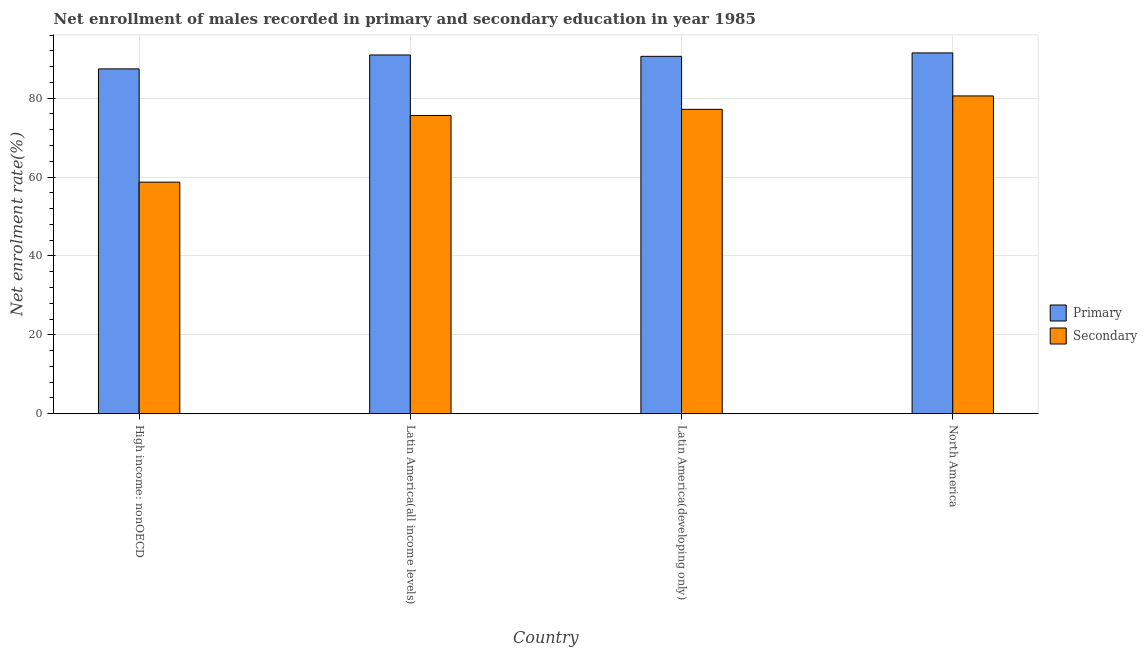Are the number of bars per tick equal to the number of legend labels?
Your response must be concise. Yes. How many bars are there on the 4th tick from the right?
Provide a succinct answer. 2. What is the enrollment rate in secondary education in North America?
Offer a terse response. 80.57. Across all countries, what is the maximum enrollment rate in primary education?
Ensure brevity in your answer.  91.47. Across all countries, what is the minimum enrollment rate in secondary education?
Your answer should be compact. 58.71. In which country was the enrollment rate in primary education maximum?
Ensure brevity in your answer.  North America. In which country was the enrollment rate in primary education minimum?
Provide a succinct answer. High income: nonOECD. What is the total enrollment rate in secondary education in the graph?
Give a very brief answer. 292.08. What is the difference between the enrollment rate in secondary education in High income: nonOECD and that in Latin America(all income levels)?
Keep it short and to the point. -16.91. What is the difference between the enrollment rate in primary education in High income: nonOECD and the enrollment rate in secondary education in North America?
Your response must be concise. 6.85. What is the average enrollment rate in primary education per country?
Ensure brevity in your answer.  90.11. What is the difference between the enrollment rate in secondary education and enrollment rate in primary education in High income: nonOECD?
Your answer should be compact. -28.71. In how many countries, is the enrollment rate in primary education greater than 44 %?
Give a very brief answer. 4. What is the ratio of the enrollment rate in secondary education in High income: nonOECD to that in North America?
Provide a succinct answer. 0.73. Is the enrollment rate in secondary education in High income: nonOECD less than that in Latin America(all income levels)?
Your response must be concise. Yes. Is the difference between the enrollment rate in primary education in High income: nonOECD and Latin America(all income levels) greater than the difference between the enrollment rate in secondary education in High income: nonOECD and Latin America(all income levels)?
Your answer should be very brief. Yes. What is the difference between the highest and the second highest enrollment rate in secondary education?
Make the answer very short. 3.4. What is the difference between the highest and the lowest enrollment rate in secondary education?
Offer a very short reply. 21.86. Is the sum of the enrollment rate in secondary education in Latin America(developing only) and North America greater than the maximum enrollment rate in primary education across all countries?
Keep it short and to the point. Yes. What does the 2nd bar from the left in Latin America(developing only) represents?
Your answer should be very brief. Secondary. What does the 2nd bar from the right in High income: nonOECD represents?
Give a very brief answer. Primary. Are all the bars in the graph horizontal?
Provide a succinct answer. No. How many countries are there in the graph?
Your answer should be very brief. 4. What is the difference between two consecutive major ticks on the Y-axis?
Provide a succinct answer. 20. Does the graph contain any zero values?
Give a very brief answer. No. Where does the legend appear in the graph?
Make the answer very short. Center right. What is the title of the graph?
Your answer should be very brief. Net enrollment of males recorded in primary and secondary education in year 1985. Does "Forest" appear as one of the legend labels in the graph?
Offer a terse response. No. What is the label or title of the X-axis?
Your answer should be compact. Country. What is the label or title of the Y-axis?
Your answer should be very brief. Net enrolment rate(%). What is the Net enrolment rate(%) in Primary in High income: nonOECD?
Offer a very short reply. 87.42. What is the Net enrolment rate(%) in Secondary in High income: nonOECD?
Your response must be concise. 58.71. What is the Net enrolment rate(%) of Primary in Latin America(all income levels)?
Your response must be concise. 90.95. What is the Net enrolment rate(%) in Secondary in Latin America(all income levels)?
Ensure brevity in your answer.  75.62. What is the Net enrolment rate(%) of Primary in Latin America(developing only)?
Ensure brevity in your answer.  90.61. What is the Net enrolment rate(%) in Secondary in Latin America(developing only)?
Your response must be concise. 77.17. What is the Net enrolment rate(%) of Primary in North America?
Offer a very short reply. 91.47. What is the Net enrolment rate(%) of Secondary in North America?
Your answer should be compact. 80.57. Across all countries, what is the maximum Net enrolment rate(%) of Primary?
Keep it short and to the point. 91.47. Across all countries, what is the maximum Net enrolment rate(%) in Secondary?
Offer a terse response. 80.57. Across all countries, what is the minimum Net enrolment rate(%) in Primary?
Your answer should be compact. 87.42. Across all countries, what is the minimum Net enrolment rate(%) in Secondary?
Your response must be concise. 58.71. What is the total Net enrolment rate(%) of Primary in the graph?
Offer a terse response. 360.46. What is the total Net enrolment rate(%) of Secondary in the graph?
Your response must be concise. 292.08. What is the difference between the Net enrolment rate(%) in Primary in High income: nonOECD and that in Latin America(all income levels)?
Make the answer very short. -3.53. What is the difference between the Net enrolment rate(%) of Secondary in High income: nonOECD and that in Latin America(all income levels)?
Give a very brief answer. -16.91. What is the difference between the Net enrolment rate(%) of Primary in High income: nonOECD and that in Latin America(developing only)?
Your response must be concise. -3.19. What is the difference between the Net enrolment rate(%) in Secondary in High income: nonOECD and that in Latin America(developing only)?
Ensure brevity in your answer.  -18.46. What is the difference between the Net enrolment rate(%) in Primary in High income: nonOECD and that in North America?
Make the answer very short. -4.05. What is the difference between the Net enrolment rate(%) of Secondary in High income: nonOECD and that in North America?
Offer a terse response. -21.86. What is the difference between the Net enrolment rate(%) in Primary in Latin America(all income levels) and that in Latin America(developing only)?
Make the answer very short. 0.34. What is the difference between the Net enrolment rate(%) of Secondary in Latin America(all income levels) and that in Latin America(developing only)?
Your answer should be compact. -1.55. What is the difference between the Net enrolment rate(%) of Primary in Latin America(all income levels) and that in North America?
Provide a short and direct response. -0.52. What is the difference between the Net enrolment rate(%) of Secondary in Latin America(all income levels) and that in North America?
Make the answer very short. -4.95. What is the difference between the Net enrolment rate(%) of Primary in Latin America(developing only) and that in North America?
Offer a terse response. -0.87. What is the difference between the Net enrolment rate(%) in Secondary in Latin America(developing only) and that in North America?
Your answer should be very brief. -3.4. What is the difference between the Net enrolment rate(%) in Primary in High income: nonOECD and the Net enrolment rate(%) in Secondary in Latin America(all income levels)?
Provide a succinct answer. 11.8. What is the difference between the Net enrolment rate(%) in Primary in High income: nonOECD and the Net enrolment rate(%) in Secondary in Latin America(developing only)?
Give a very brief answer. 10.25. What is the difference between the Net enrolment rate(%) in Primary in High income: nonOECD and the Net enrolment rate(%) in Secondary in North America?
Give a very brief answer. 6.85. What is the difference between the Net enrolment rate(%) of Primary in Latin America(all income levels) and the Net enrolment rate(%) of Secondary in Latin America(developing only)?
Give a very brief answer. 13.78. What is the difference between the Net enrolment rate(%) in Primary in Latin America(all income levels) and the Net enrolment rate(%) in Secondary in North America?
Your answer should be compact. 10.38. What is the difference between the Net enrolment rate(%) of Primary in Latin America(developing only) and the Net enrolment rate(%) of Secondary in North America?
Offer a terse response. 10.04. What is the average Net enrolment rate(%) of Primary per country?
Ensure brevity in your answer.  90.11. What is the average Net enrolment rate(%) in Secondary per country?
Keep it short and to the point. 73.02. What is the difference between the Net enrolment rate(%) of Primary and Net enrolment rate(%) of Secondary in High income: nonOECD?
Provide a succinct answer. 28.71. What is the difference between the Net enrolment rate(%) in Primary and Net enrolment rate(%) in Secondary in Latin America(all income levels)?
Offer a terse response. 15.33. What is the difference between the Net enrolment rate(%) in Primary and Net enrolment rate(%) in Secondary in Latin America(developing only)?
Ensure brevity in your answer.  13.44. What is the difference between the Net enrolment rate(%) in Primary and Net enrolment rate(%) in Secondary in North America?
Your answer should be very brief. 10.9. What is the ratio of the Net enrolment rate(%) in Primary in High income: nonOECD to that in Latin America(all income levels)?
Ensure brevity in your answer.  0.96. What is the ratio of the Net enrolment rate(%) of Secondary in High income: nonOECD to that in Latin America(all income levels)?
Give a very brief answer. 0.78. What is the ratio of the Net enrolment rate(%) in Primary in High income: nonOECD to that in Latin America(developing only)?
Give a very brief answer. 0.96. What is the ratio of the Net enrolment rate(%) of Secondary in High income: nonOECD to that in Latin America(developing only)?
Offer a terse response. 0.76. What is the ratio of the Net enrolment rate(%) of Primary in High income: nonOECD to that in North America?
Provide a succinct answer. 0.96. What is the ratio of the Net enrolment rate(%) in Secondary in High income: nonOECD to that in North America?
Give a very brief answer. 0.73. What is the ratio of the Net enrolment rate(%) in Secondary in Latin America(all income levels) to that in Latin America(developing only)?
Your answer should be compact. 0.98. What is the ratio of the Net enrolment rate(%) in Primary in Latin America(all income levels) to that in North America?
Provide a succinct answer. 0.99. What is the ratio of the Net enrolment rate(%) of Secondary in Latin America(all income levels) to that in North America?
Your answer should be compact. 0.94. What is the ratio of the Net enrolment rate(%) in Secondary in Latin America(developing only) to that in North America?
Provide a succinct answer. 0.96. What is the difference between the highest and the second highest Net enrolment rate(%) of Primary?
Provide a succinct answer. 0.52. What is the difference between the highest and the second highest Net enrolment rate(%) in Secondary?
Your answer should be compact. 3.4. What is the difference between the highest and the lowest Net enrolment rate(%) of Primary?
Your answer should be compact. 4.05. What is the difference between the highest and the lowest Net enrolment rate(%) in Secondary?
Your answer should be very brief. 21.86. 